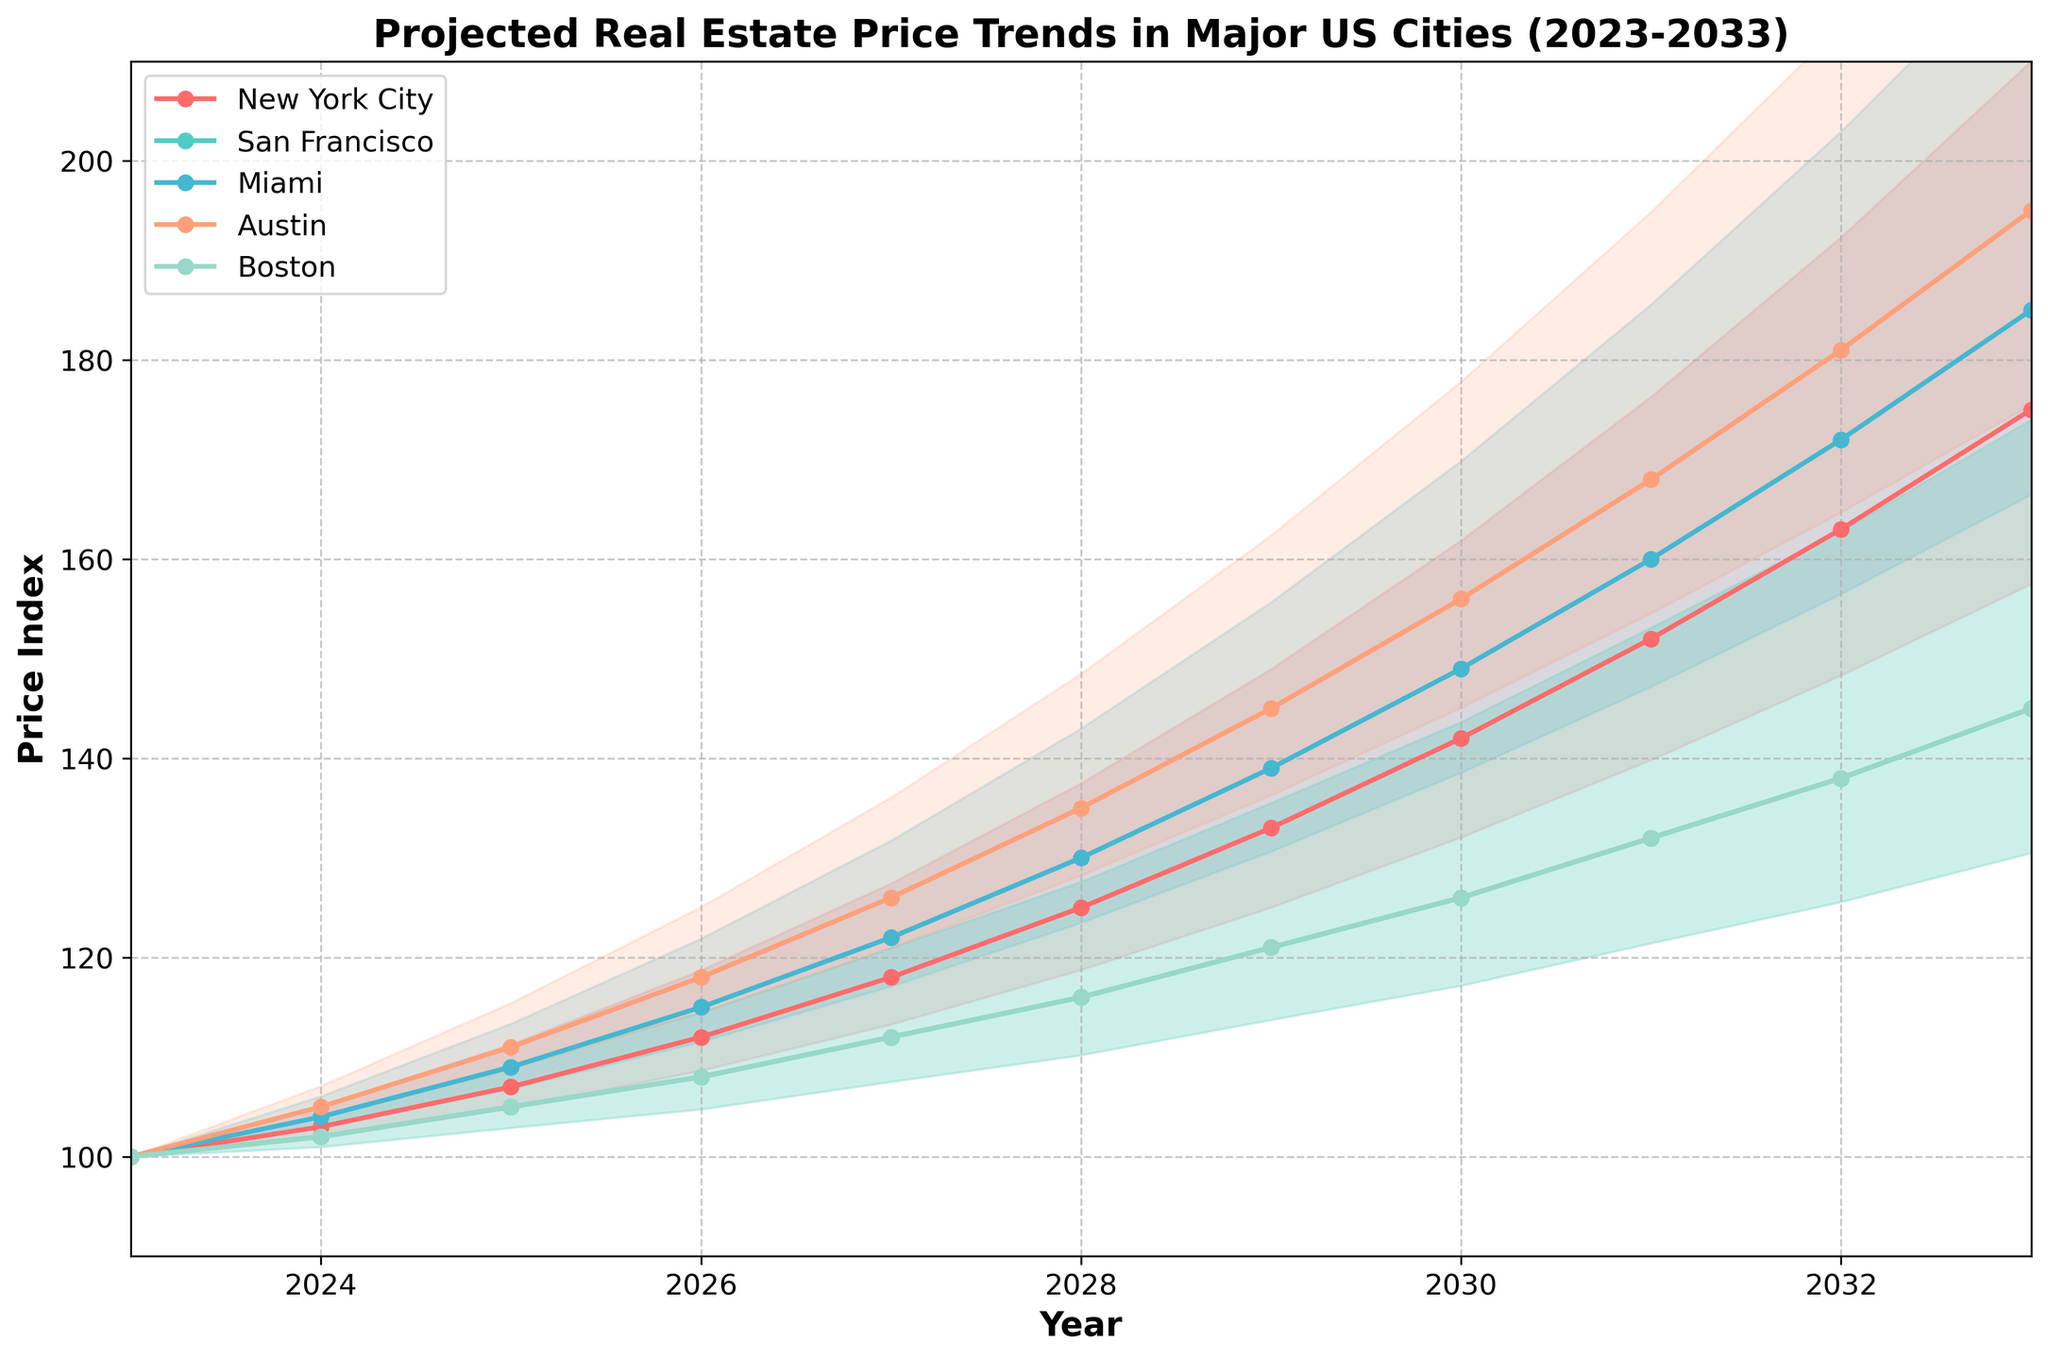What is the title of the figure? The title of the figure can be found at the top of the plot. The plot title provides a summary of what the figure represents.
Answer: Projected Real Estate Price Trends in Major US Cities (2023-2033) How many cities are represented in the figure? The number of cities can be determined by counting the distinct labels or lines representing different cities in the legend or plot.
Answer: 5 Which city has the highest projected real estate price index in 2033? To determine this, look at the endpoints of each city's line in the plot at the year 2033. The city with the highest value is the one with the highest endpoint.
Answer: Austin What are the projected real estate price indices for New York City and San Francisco in 2027? Identify the value of each city's line at the year 2027 from the x-axis and the respective y-axis value.
Answer: New York City: 118, San Francisco: 112 By how much is Austin's projected real estate price index expected to increase from 2023 to 2033? Subtract Austin's value in 2023 from its value in 2033: 195 - 100 = 95
Answer: 95 Which year does Boston surpass a price index of 130? Determine the year when Boston's line first crosses the y-axis value of 130.
Answer: 2029 Compare the projected trends of New York City and Miami. Which city has a steeper increase from 2023 to 2033? To find which city has a steeper increase, compare the slopes of the lines representing each city's trajectory over the years. Calculate the difference in values for each city and determine which difference is greater: New York: (175-100)=75, Miami: (185-100)=85, so Miami has a steeper increase.
Answer: Miami Between which years does San Francisco's projected real estate price index see the highest increase? To find the highest increase, compare the year-to-year differences for San Francisco's values and determine the pair of years with the largest difference. From data: 145 - 138 (2032-2033) = 7
Answer: 2032-2033 What is the average projected price index of Boston from 2028 to 2032? Add the values of Boston's indices from 2028, 2029, 2030, 2031, and 2032, and then divide by the number of years: (116 + 121 + 126 + 132 + 138) / 5 = 126.6.
Answer: 126.6 Which city has the least fluctuation in its confidence interval over the years? Assess the width of the shaded confidence intervals for each city over the years. Look for the city with the most narrow and consistent interval width.
Answer: New York City 